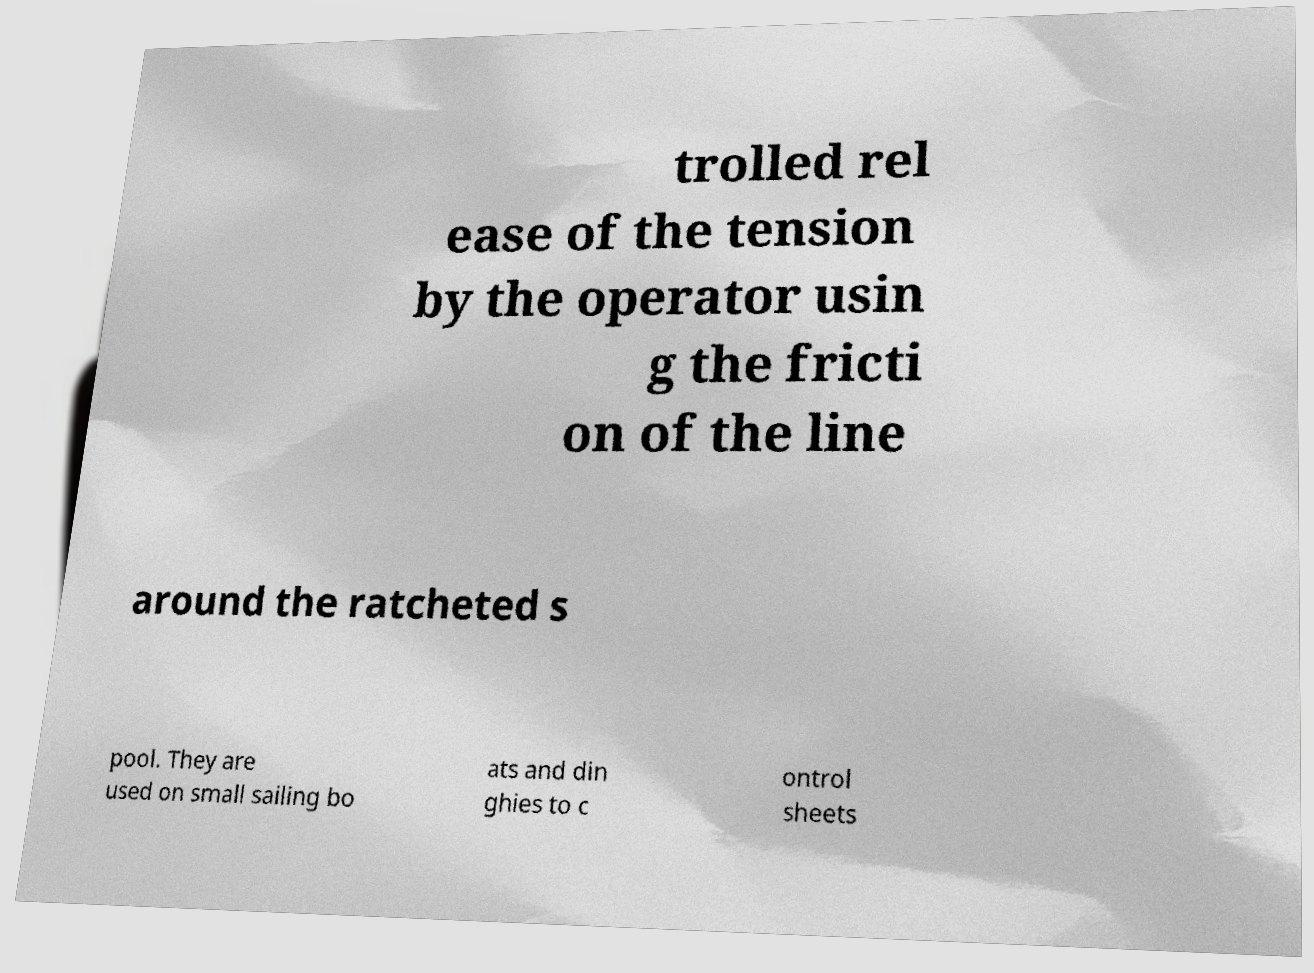Can you accurately transcribe the text from the provided image for me? trolled rel ease of the tension by the operator usin g the fricti on of the line around the ratcheted s pool. They are used on small sailing bo ats and din ghies to c ontrol sheets 